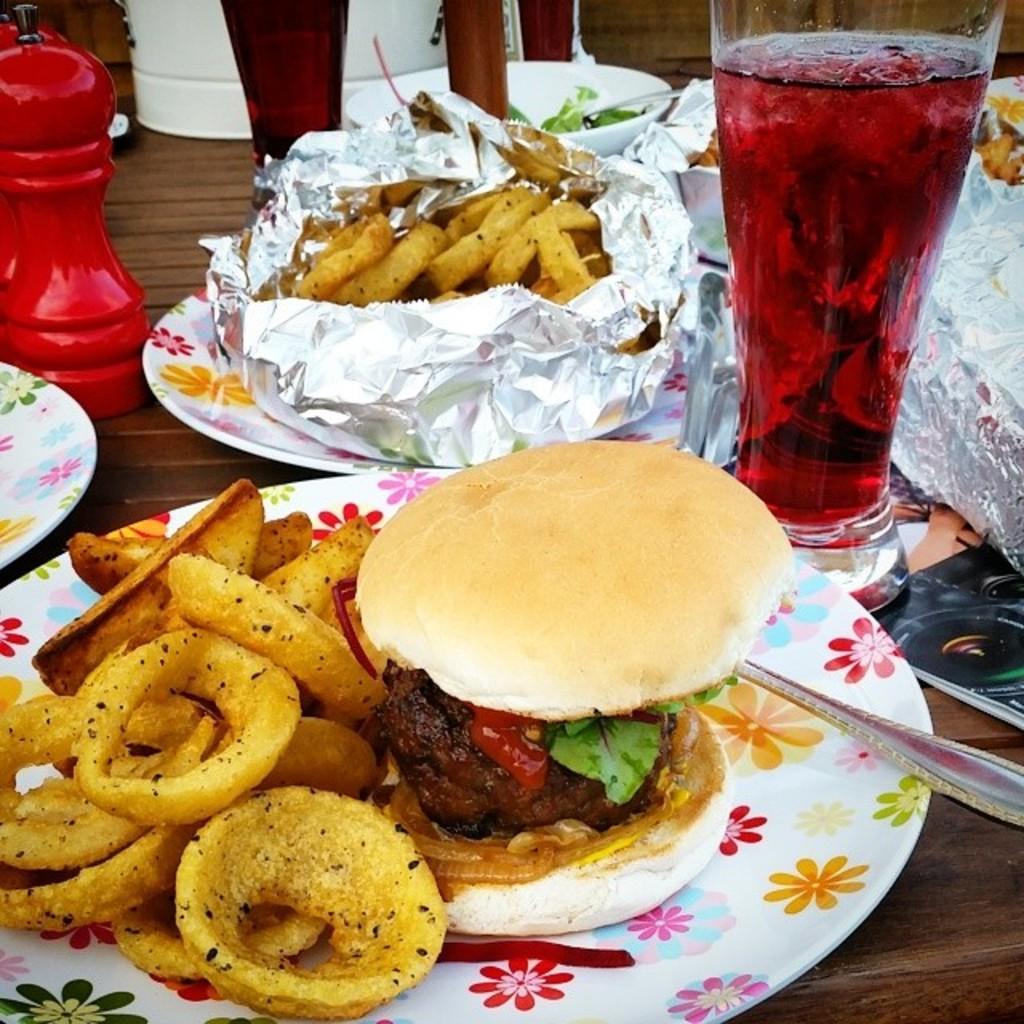Could you give a brief overview of what you see in this image? In this image I can see glasses, bottles, plates, vessels, spoons and food items may be on the table. This image is taken may be during a day. 